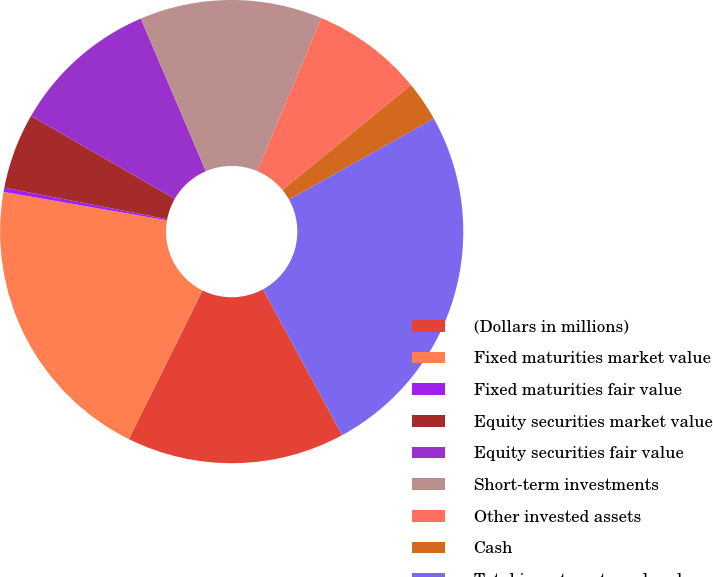<chart> <loc_0><loc_0><loc_500><loc_500><pie_chart><fcel>(Dollars in millions)<fcel>Fixed maturities market value<fcel>Fixed maturities fair value<fcel>Equity securities market value<fcel>Equity securities fair value<fcel>Short-term investments<fcel>Other invested assets<fcel>Cash<fcel>Total investments and cash<nl><fcel>15.24%<fcel>20.42%<fcel>0.3%<fcel>5.28%<fcel>10.26%<fcel>12.75%<fcel>7.77%<fcel>2.79%<fcel>25.2%<nl></chart> 